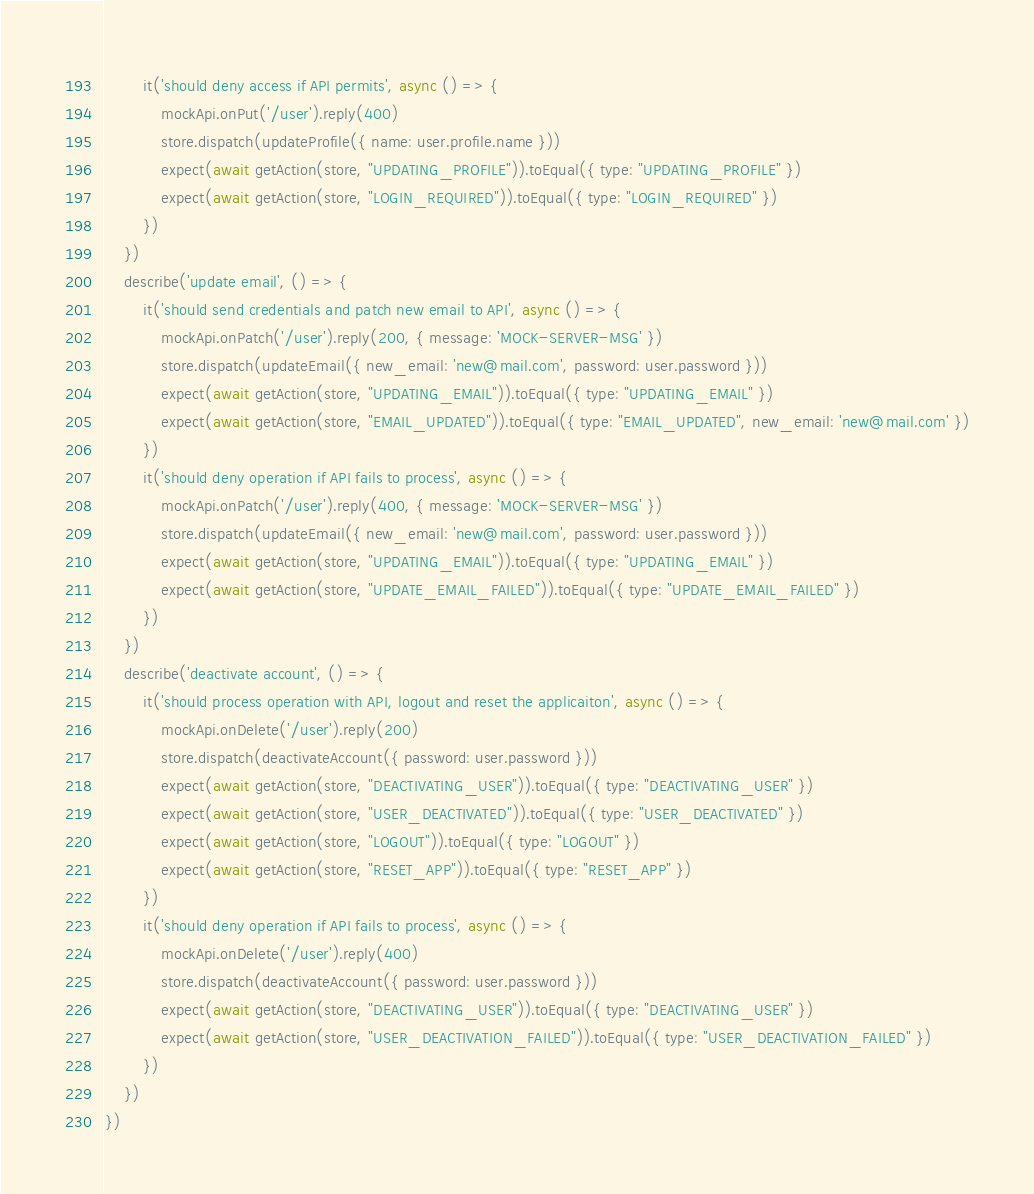<code> <loc_0><loc_0><loc_500><loc_500><_JavaScript_>        it('should deny access if API permits', async () => {
            mockApi.onPut('/user').reply(400)
            store.dispatch(updateProfile({ name: user.profile.name }))
            expect(await getAction(store, "UPDATING_PROFILE")).toEqual({ type: "UPDATING_PROFILE" })
            expect(await getAction(store, "LOGIN_REQUIRED")).toEqual({ type: "LOGIN_REQUIRED" })
        })
    })
    describe('update email', () => {
        it('should send credentials and patch new email to API', async () => {
            mockApi.onPatch('/user').reply(200, { message: 'MOCK-SERVER-MSG' })
            store.dispatch(updateEmail({ new_email: 'new@mail.com', password: user.password }))
            expect(await getAction(store, "UPDATING_EMAIL")).toEqual({ type: "UPDATING_EMAIL" })
            expect(await getAction(store, "EMAIL_UPDATED")).toEqual({ type: "EMAIL_UPDATED", new_email: 'new@mail.com' })
        })
        it('should deny operation if API fails to process', async () => {
            mockApi.onPatch('/user').reply(400, { message: 'MOCK-SERVER-MSG' })
            store.dispatch(updateEmail({ new_email: 'new@mail.com', password: user.password }))
            expect(await getAction(store, "UPDATING_EMAIL")).toEqual({ type: "UPDATING_EMAIL" })
            expect(await getAction(store, "UPDATE_EMAIL_FAILED")).toEqual({ type: "UPDATE_EMAIL_FAILED" })
        })
    })
    describe('deactivate account', () => {
        it('should process operation with API, logout and reset the applicaiton', async () => {
            mockApi.onDelete('/user').reply(200)
            store.dispatch(deactivateAccount({ password: user.password }))
            expect(await getAction(store, "DEACTIVATING_USER")).toEqual({ type: "DEACTIVATING_USER" })
            expect(await getAction(store, "USER_DEACTIVATED")).toEqual({ type: "USER_DEACTIVATED" })
            expect(await getAction(store, "LOGOUT")).toEqual({ type: "LOGOUT" })
            expect(await getAction(store, "RESET_APP")).toEqual({ type: "RESET_APP" })
        })
        it('should deny operation if API fails to process', async () => {
            mockApi.onDelete('/user').reply(400)
            store.dispatch(deactivateAccount({ password: user.password }))
            expect(await getAction(store, "DEACTIVATING_USER")).toEqual({ type: "DEACTIVATING_USER" })
            expect(await getAction(store, "USER_DEACTIVATION_FAILED")).toEqual({ type: "USER_DEACTIVATION_FAILED" })
        })
    })
})</code> 